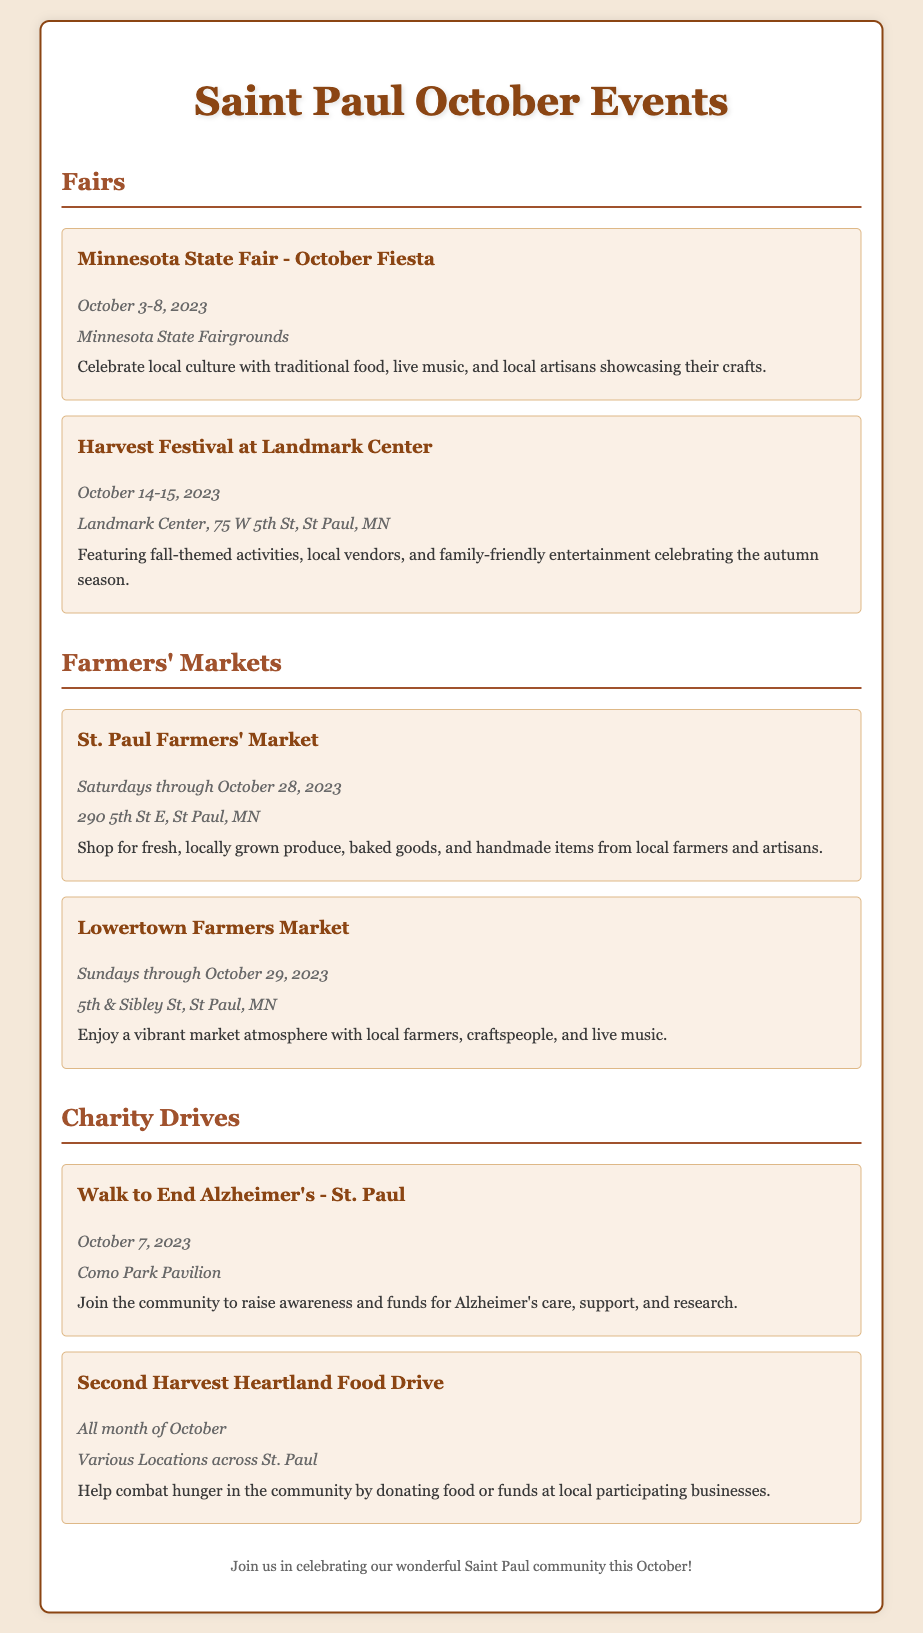what are the dates for the Minnesota State Fair - October Fiesta? The dates for this event are explicitly listed as October 3-8, 2023.
Answer: October 3-8, 2023 where is the Harvest Festival at Landmark Center held? The location for this festival is provided as Landmark Center, 75 W 5th St, St Paul, MN.
Answer: Landmark Center, 75 W 5th St, St Paul, MN when does the St. Paul Farmers' Market operate through? The document specifies that it operates Saturdays through October 28, 2023.
Answer: October 28, 2023 what is the purpose of the Walk to End Alzheimer's event? The document states this event is to raise awareness and funds for Alzheimer's care, support, and research.
Answer: Raise awareness and funds for Alzheimer's care how long does the Second Harvest Heartland Food Drive last? The document mentions that it lasts for the entire month of October.
Answer: All month of October how many farmers' markets are listed in the document? The document lists two farmers' markets: St. Paul Farmers' Market and Lowertown Farmers Market.
Answer: Two what type of local activities can one expect at the Harvest Festival? The document describes fall-themed activities and family-friendly entertainment among other things.
Answer: Fall-themed activities, family-friendly entertainment which charity drive takes place on October 7? The document indicates that the Walk to End Alzheimer's takes place on this date.
Answer: Walk to End Alzheimer's what is featured at the Lowertown Farmers Market? The document highlights local farmers, craftspeople, and live music as features of this market.
Answer: Local farmers, craftspeople, live music 